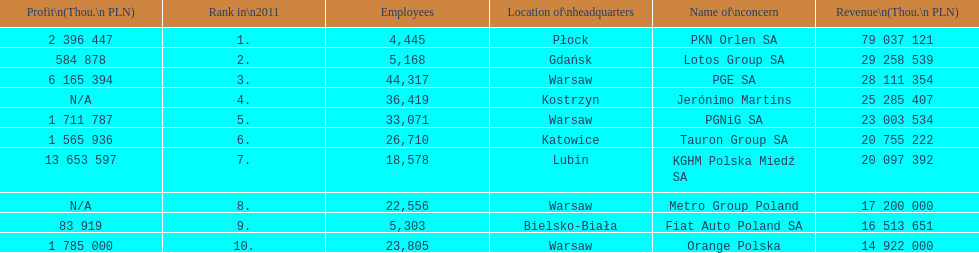What company has the top number of employees? PGE SA. 